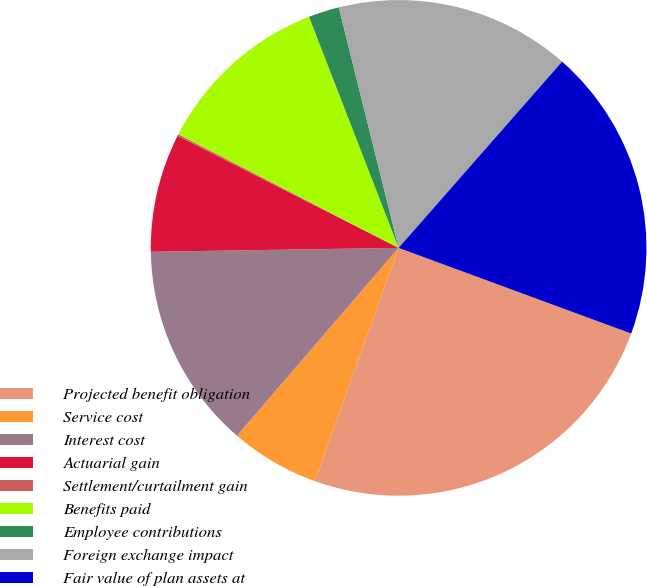Convert chart to OTSL. <chart><loc_0><loc_0><loc_500><loc_500><pie_chart><fcel>Projected benefit obligation<fcel>Service cost<fcel>Interest cost<fcel>Actuarial gain<fcel>Settlement/curtailment gain<fcel>Benefits paid<fcel>Employee contributions<fcel>Foreign exchange impact<fcel>Fair value of plan assets at<nl><fcel>24.87%<fcel>5.82%<fcel>13.44%<fcel>7.72%<fcel>0.11%<fcel>11.53%<fcel>2.01%<fcel>15.34%<fcel>19.15%<nl></chart> 